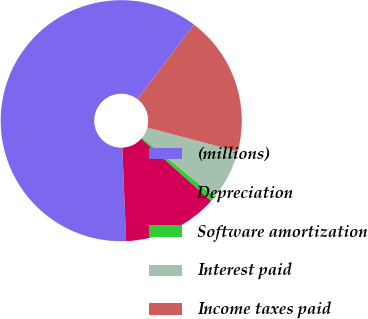Convert chart. <chart><loc_0><loc_0><loc_500><loc_500><pie_chart><fcel>(millions)<fcel>Depreciation<fcel>Software amortization<fcel>Interest paid<fcel>Income taxes paid<nl><fcel>60.97%<fcel>12.77%<fcel>0.72%<fcel>6.74%<fcel>18.79%<nl></chart> 